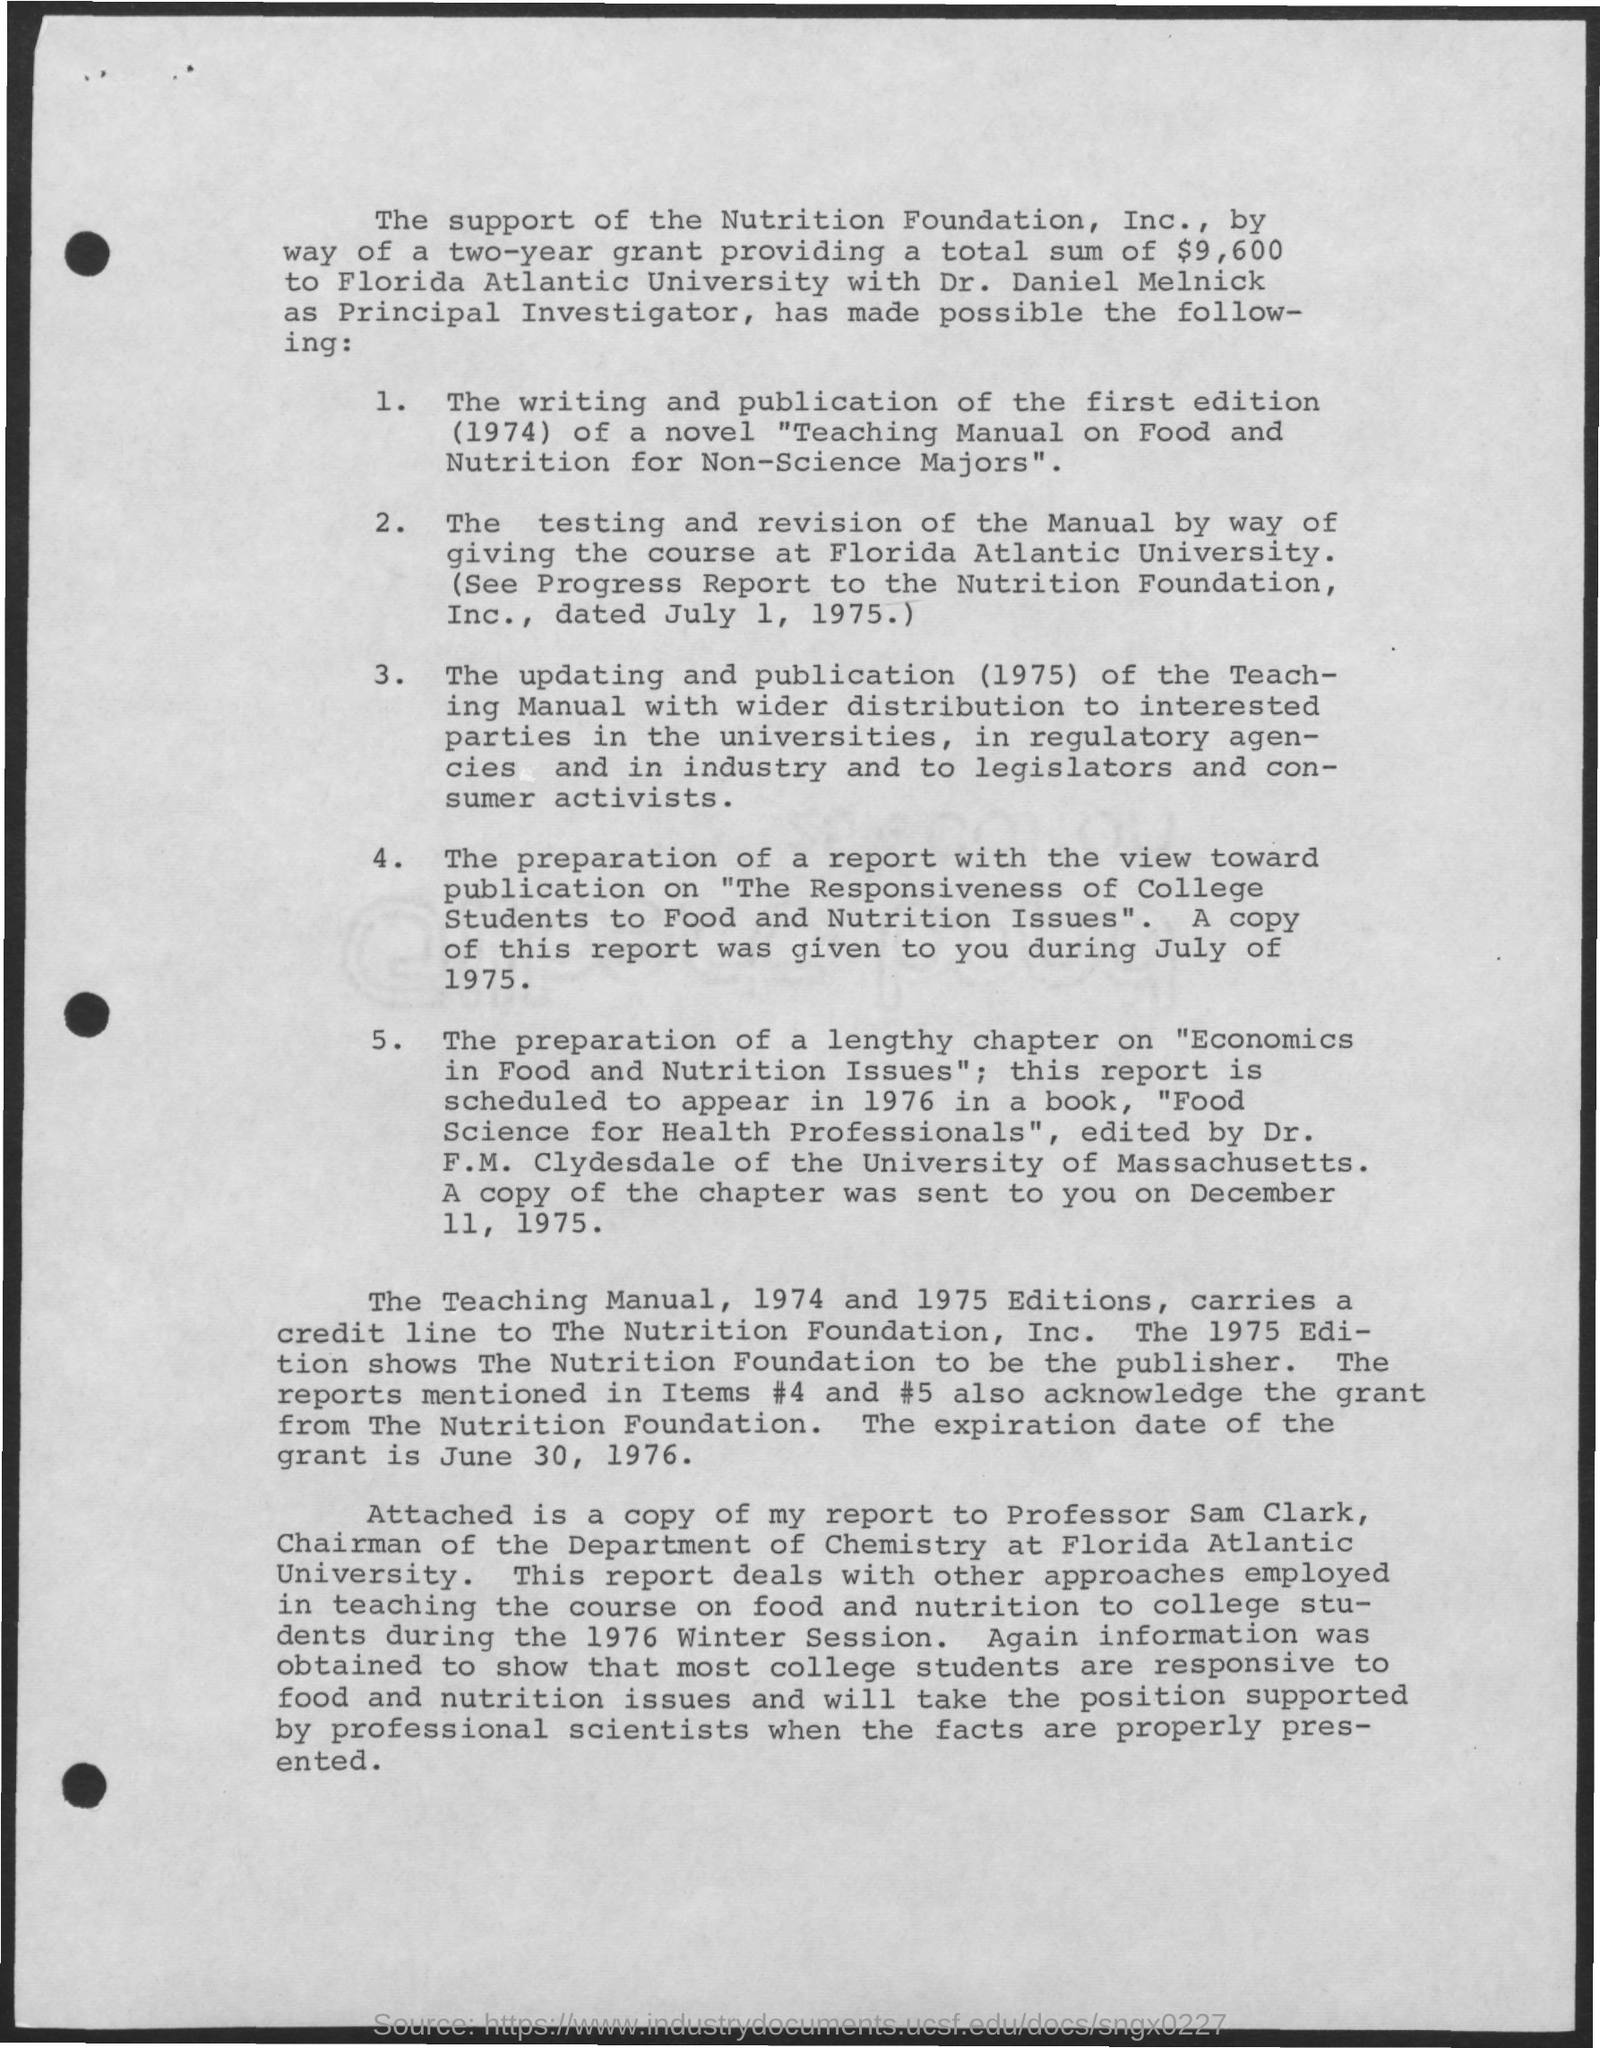Point out several critical features in this image. Florida Atlantic University's Department of Chemistry is headed by Professor Sam Clark, who serves as the Chairman. The expiration date of the grant is June 30, 1976. The Principal Investigator is Dr. Daniel Melnick. The total sum of a two-year grant is $9,600. 